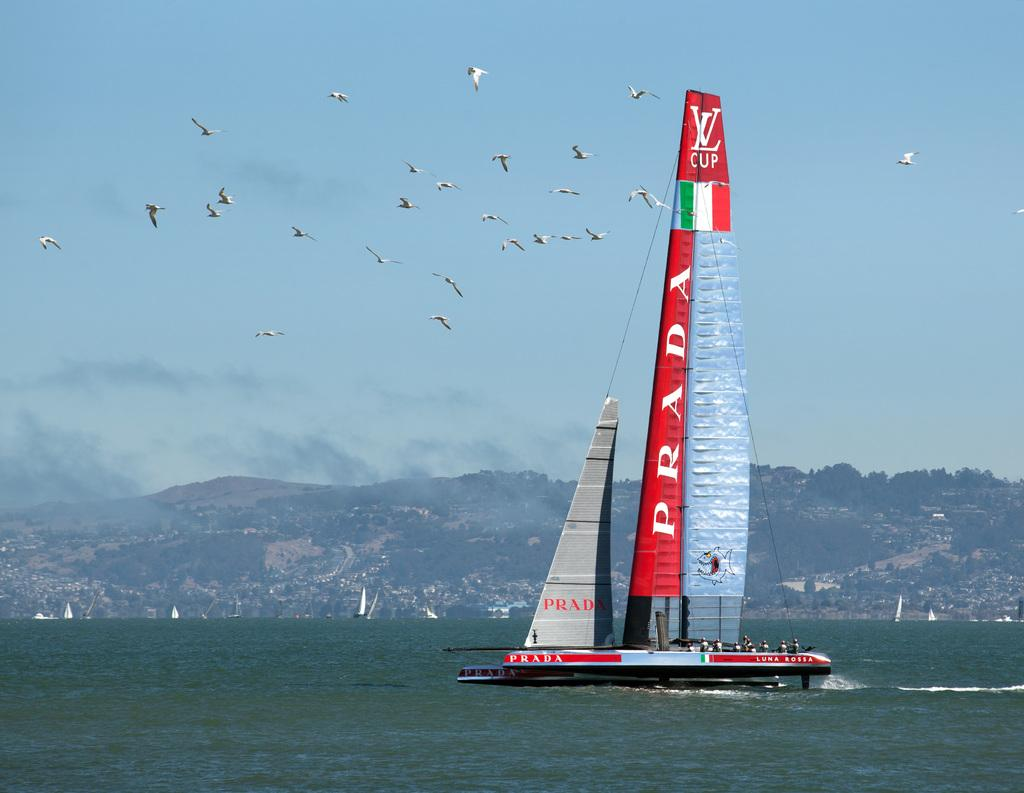Provide a one-sentence caption for the provided image. a boat that has the word Prada on it. 